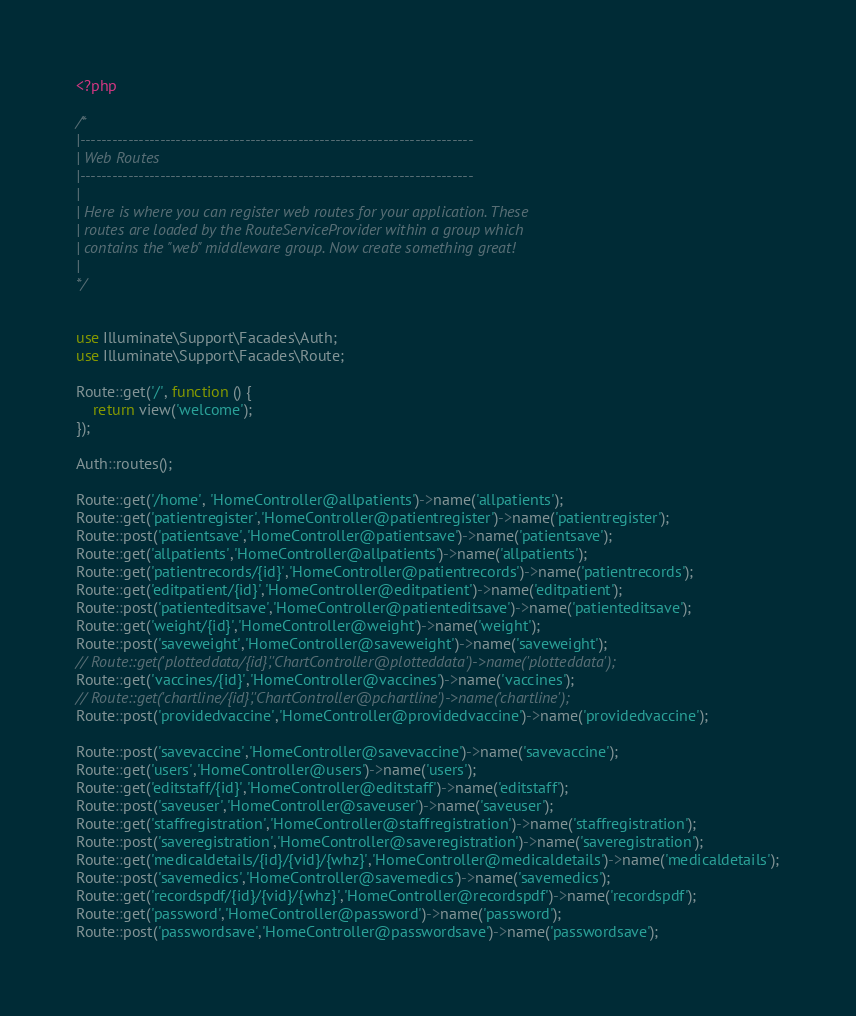<code> <loc_0><loc_0><loc_500><loc_500><_PHP_><?php

/*
|--------------------------------------------------------------------------
| Web Routes
|--------------------------------------------------------------------------
|
| Here is where you can register web routes for your application. These
| routes are loaded by the RouteServiceProvider within a group which
| contains the "web" middleware group. Now create something great!
|
*/


use Illuminate\Support\Facades\Auth;
use Illuminate\Support\Facades\Route;

Route::get('/', function () {
    return view('welcome');
});

Auth::routes();

Route::get('/home', 'HomeController@allpatients')->name('allpatients');
Route::get('patientregister','HomeController@patientregister')->name('patientregister');
Route::post('patientsave','HomeController@patientsave')->name('patientsave');
Route::get('allpatients','HomeController@allpatients')->name('allpatients');
Route::get('patientrecords/{id}','HomeController@patientrecords')->name('patientrecords');
Route::get('editpatient/{id}','HomeController@editpatient')->name('editpatient');
Route::post('patienteditsave','HomeController@patienteditsave')->name('patienteditsave');
Route::get('weight/{id}','HomeController@weight')->name('weight');
Route::post('saveweight','HomeController@saveweight')->name('saveweight');
// Route::get('plotteddata/{id}','ChartController@plotteddata')->name('plotteddata');
Route::get('vaccines/{id}','HomeController@vaccines')->name('vaccines');
// Route::get('chartline/{id}','ChartController@pchartline')->name('chartline');
Route::post('providedvaccine','HomeController@providedvaccine')->name('providedvaccine');

Route::post('savevaccine','HomeController@savevaccine')->name('savevaccine');
Route::get('users','HomeController@users')->name('users');
Route::get('editstaff/{id}','HomeController@editstaff')->name('editstaff');
Route::post('saveuser','HomeController@saveuser')->name('saveuser');
Route::get('staffregistration','HomeController@staffregistration')->name('staffregistration');
Route::post('saveregistration','HomeController@saveregistration')->name('saveregistration');
Route::get('medicaldetails/{id}/{vid}/{whz}','HomeController@medicaldetails')->name('medicaldetails');
Route::post('savemedics','HomeController@savemedics')->name('savemedics');
Route::get('recordspdf/{id}/{vid}/{whz}','HomeController@recordspdf')->name('recordspdf');
Route::get('password','HomeController@password')->name('password');
Route::post('passwordsave','HomeController@passwordsave')->name('passwordsave');
</code> 